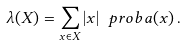Convert formula to latex. <formula><loc_0><loc_0><loc_500><loc_500>\lambda ( X ) = \sum _ { x \in X } | x | \ p r o b a ( x ) \, .</formula> 